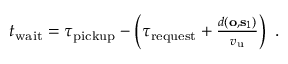<formula> <loc_0><loc_0><loc_500><loc_500>\begin{array} { r } { t _ { w a i t } = \tau _ { p i c k u p } - \left ( \tau _ { r e q u e s t } + \frac { d ( o , s _ { 1 } ) } { v _ { u } } \right ) \, . } \end{array}</formula> 